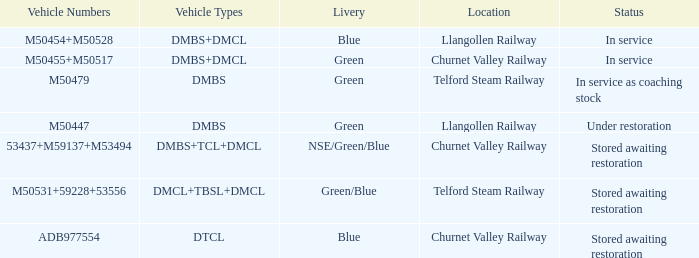What type of livery is being used as coaching stock in service? Green. 